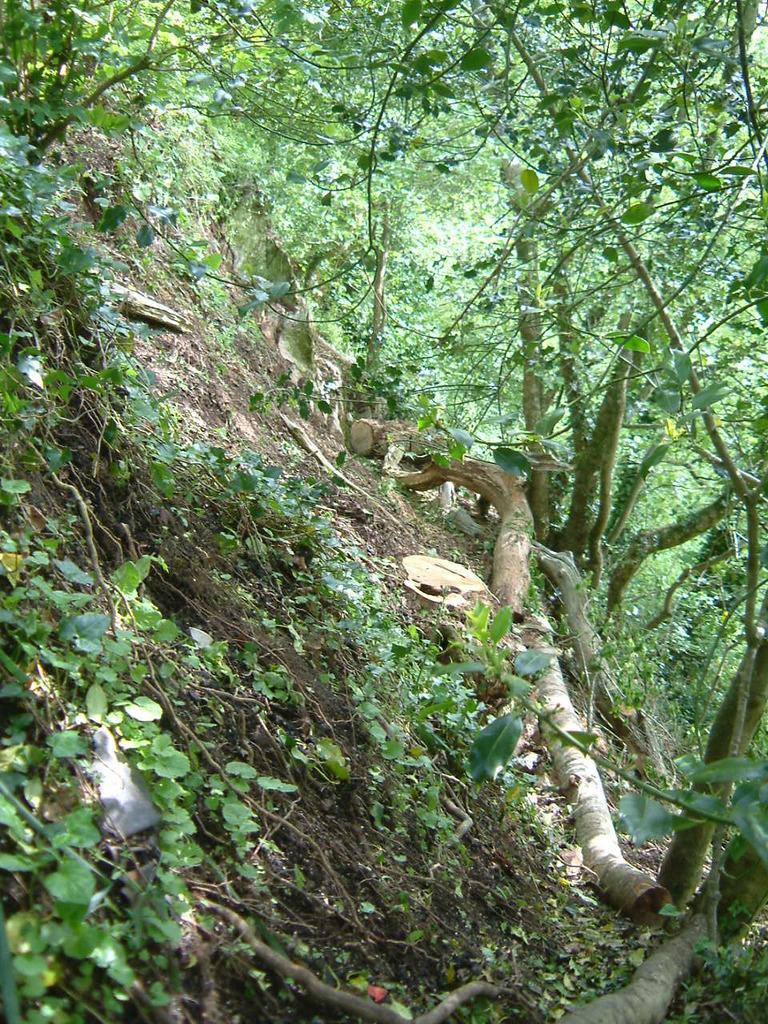Please provide a concise description of this image. In this picture we can see a few trees. 